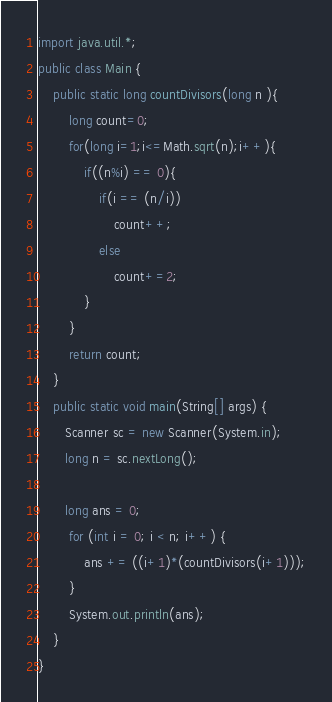<code> <loc_0><loc_0><loc_500><loc_500><_Java_>import java.util.*;
public class Main {
    public static long countDivisors(long n ){
        long count=0;
        for(long i=1;i<=Math.sqrt(n);i++){
            if((n%i) == 0){
                if(i == (n/i))
                    count++;
                else
                    count+=2;
            }
        }
        return count;
    }
    public static void main(String[] args) {
       Scanner sc = new Scanner(System.in);
       long n = sc.nextLong();

       long ans = 0;
        for (int i = 0; i < n; i++) {
            ans += ((i+1)*(countDivisors(i+1)));
        }
        System.out.println(ans);
    }
}
</code> 